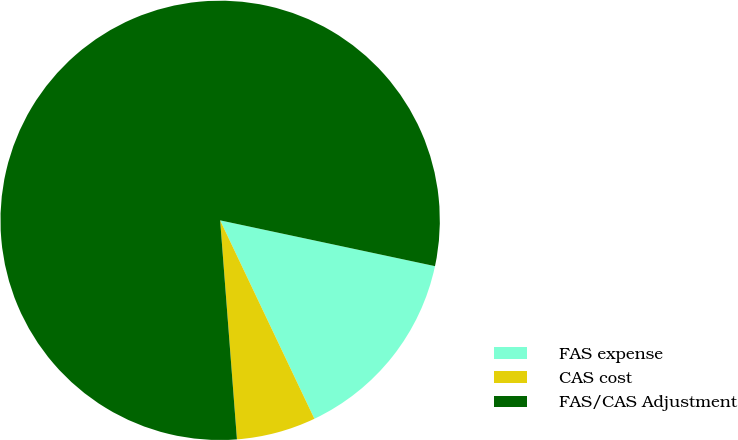<chart> <loc_0><loc_0><loc_500><loc_500><pie_chart><fcel>FAS expense<fcel>CAS cost<fcel>FAS/CAS Adjustment<nl><fcel>14.6%<fcel>5.84%<fcel>79.56%<nl></chart> 